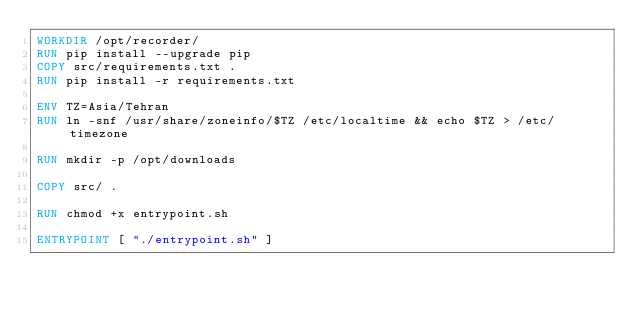Convert code to text. <code><loc_0><loc_0><loc_500><loc_500><_Dockerfile_>WORKDIR /opt/recorder/
RUN pip install --upgrade pip
COPY src/requirements.txt .
RUN pip install -r requirements.txt

ENV TZ=Asia/Tehran
RUN ln -snf /usr/share/zoneinfo/$TZ /etc/localtime && echo $TZ > /etc/timezone

RUN mkdir -p /opt/downloads

COPY src/ .

RUN chmod +x entrypoint.sh

ENTRYPOINT [ "./entrypoint.sh" ]
</code> 